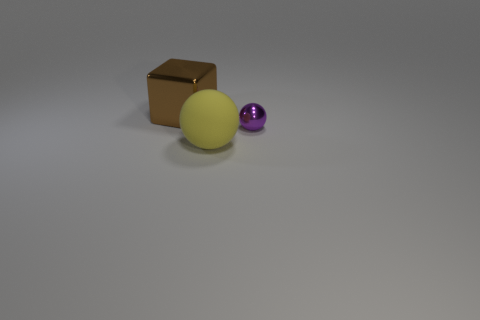Is there anything else that has the same size as the purple thing?
Provide a succinct answer. No. Is there anything else that is made of the same material as the big yellow object?
Provide a succinct answer. No. Does the shiny thing that is behind the purple shiny sphere have the same size as the big yellow rubber sphere?
Your answer should be very brief. Yes. What number of other things are the same shape as the small shiny thing?
Your response must be concise. 1. How many big objects are in front of the brown metallic object?
Keep it short and to the point. 1. What number of other objects are the same size as the shiny ball?
Make the answer very short. 0. Do the object behind the purple metal thing and the sphere to the right of the big yellow sphere have the same material?
Keep it short and to the point. Yes. There is a metal object that is the same size as the yellow rubber thing; what color is it?
Make the answer very short. Brown. Is there anything else that has the same color as the big metal cube?
Your answer should be compact. No. What is the size of the shiny object on the left side of the big thing on the right side of the big thing that is behind the matte sphere?
Keep it short and to the point. Large. 